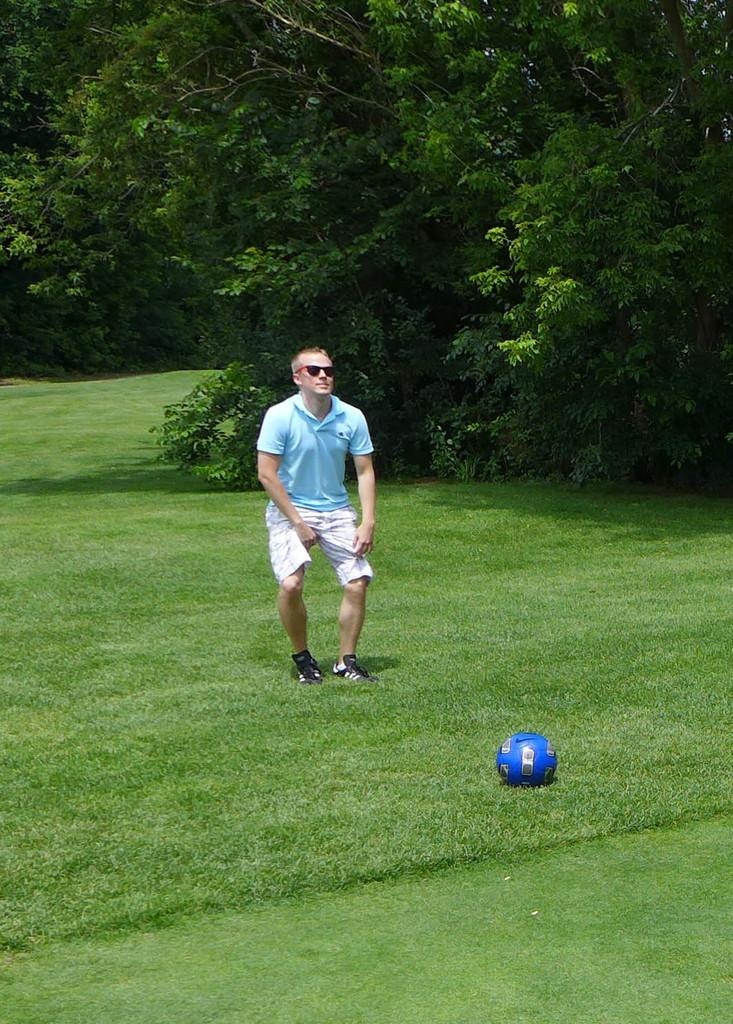What is the main subject of the image? There is a man standing in the image. Where is the man positioned in the image? The man is standing on the ground. What object is in front of the man? There is a ball in front of the man. What can be seen in the background of the image? There are trees in the background of the image. What date is circled on the calendar in the image? There is no calendar present in the image. Is the man wearing a scarf in the image? The provided facts do not mention a scarf, so we cannot determine if the man is wearing one. 